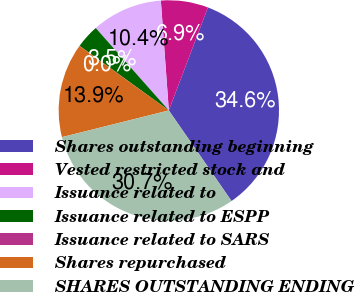Convert chart. <chart><loc_0><loc_0><loc_500><loc_500><pie_chart><fcel>Shares outstanding beginning<fcel>Vested restricted stock and<fcel>Issuance related to<fcel>Issuance related to ESPP<fcel>Issuance related to SARS<fcel>Shares repurchased<fcel>SHARES OUTSTANDING ENDING<nl><fcel>34.59%<fcel>6.93%<fcel>10.39%<fcel>3.48%<fcel>0.02%<fcel>13.85%<fcel>30.74%<nl></chart> 